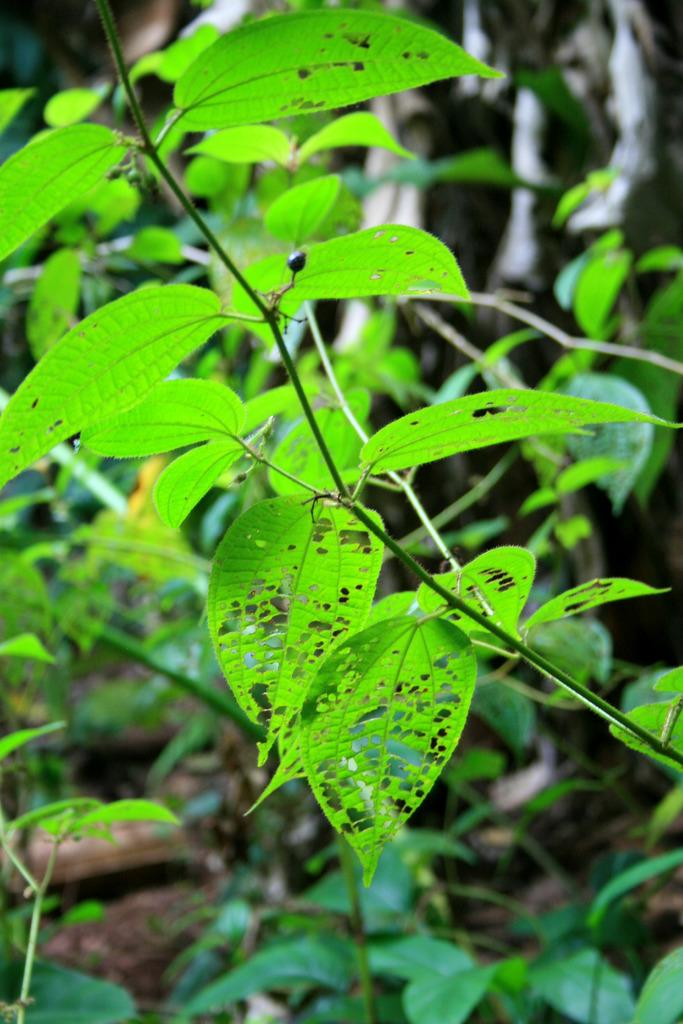What type of living organisms are present in the image? There are plants in the image. What structural components can be observed in the plants? The plants have stems and leaves. Are there any visible signs of damage to the plants in the image? Yes, some leaves in the image appear to be damaged. What type of breakfast is being served on the donkey in the image? There is no donkey or breakfast present in the image; it only features plants with stems and leaves. 